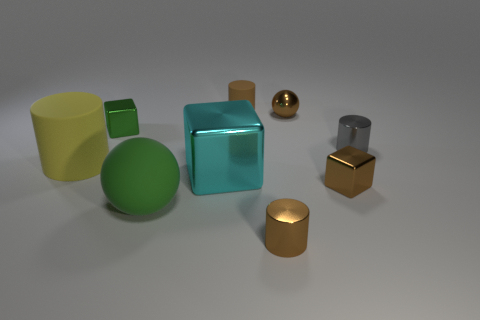Subtract all small gray shiny cylinders. How many cylinders are left? 3 Subtract all yellow cylinders. How many cylinders are left? 3 Subtract 1 blocks. How many blocks are left? 2 Subtract 1 brown cylinders. How many objects are left? 8 Subtract all cylinders. How many objects are left? 5 Subtract all purple cylinders. Subtract all cyan cubes. How many cylinders are left? 4 Subtract all green spheres. How many brown cubes are left? 1 Subtract all large metal things. Subtract all large yellow matte things. How many objects are left? 7 Add 2 large cyan metallic objects. How many large cyan metallic objects are left? 3 Add 6 small brown metallic cylinders. How many small brown metallic cylinders exist? 7 